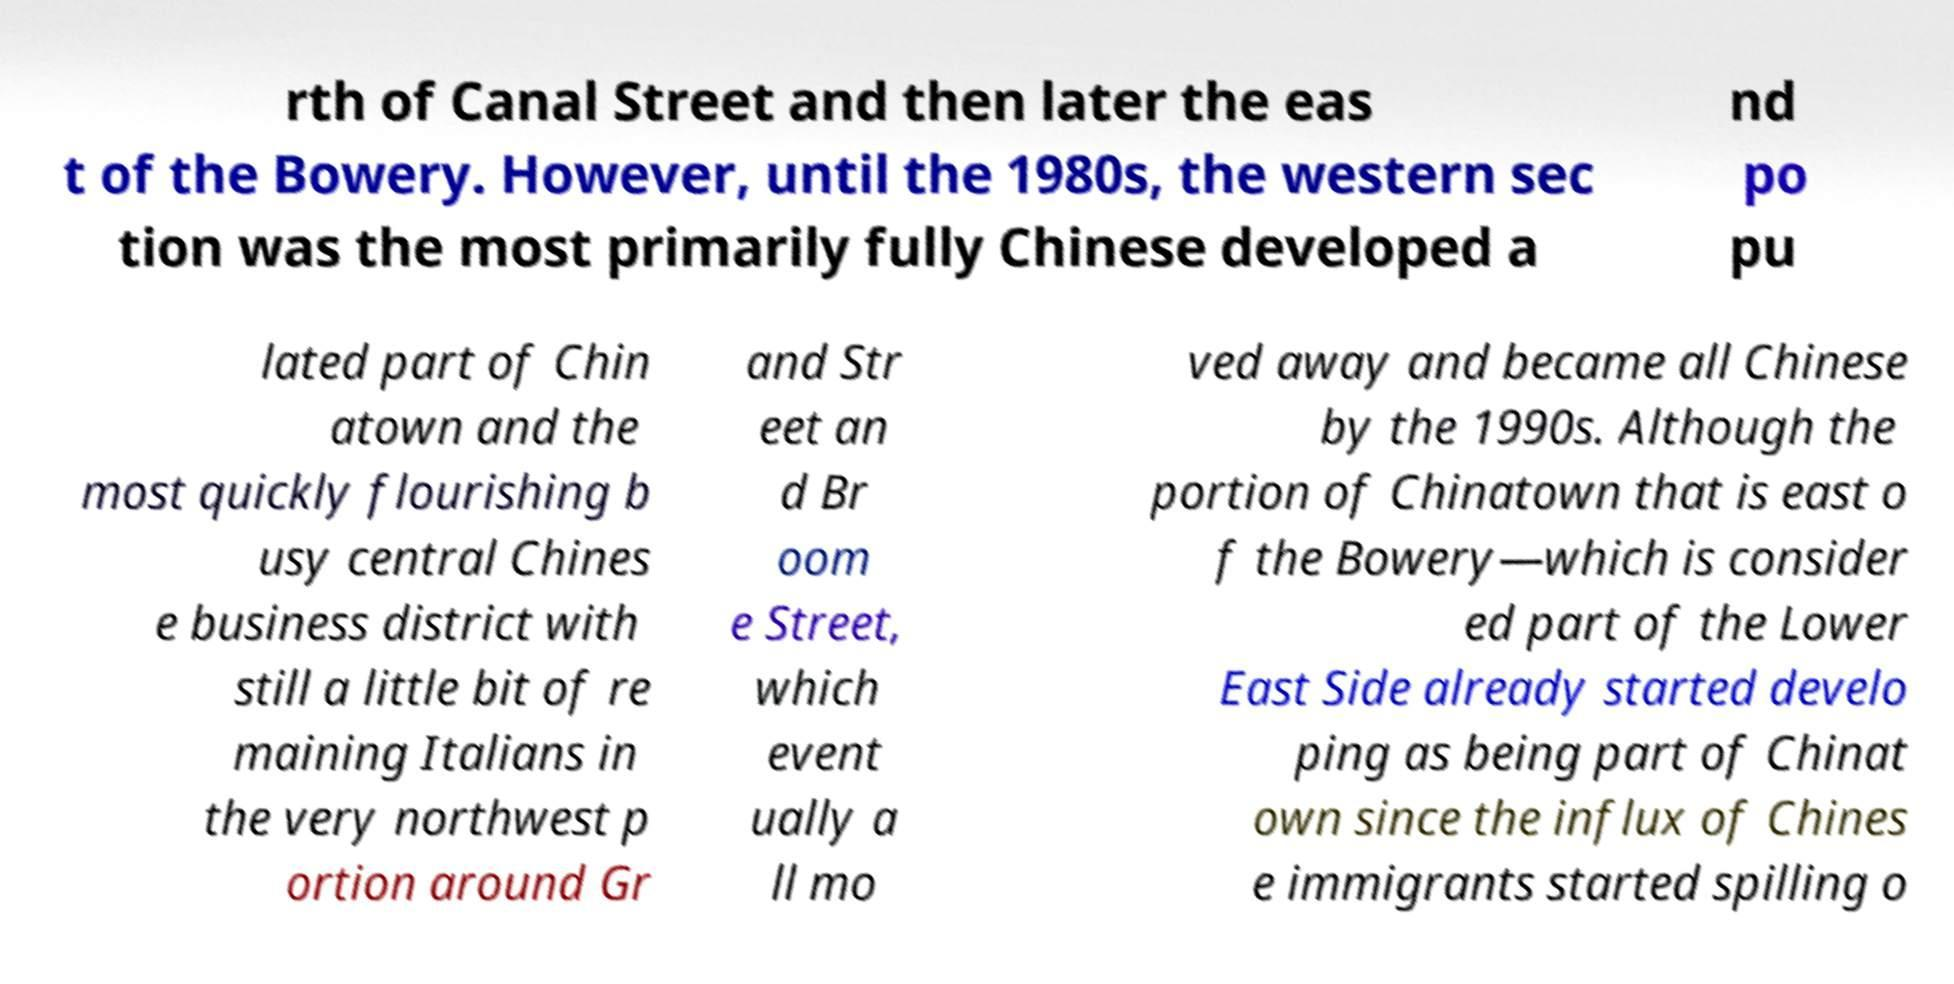Can you read and provide the text displayed in the image?This photo seems to have some interesting text. Can you extract and type it out for me? rth of Canal Street and then later the eas t of the Bowery. However, until the 1980s, the western sec tion was the most primarily fully Chinese developed a nd po pu lated part of Chin atown and the most quickly flourishing b usy central Chines e business district with still a little bit of re maining Italians in the very northwest p ortion around Gr and Str eet an d Br oom e Street, which event ually a ll mo ved away and became all Chinese by the 1990s. Although the portion of Chinatown that is east o f the Bowery—which is consider ed part of the Lower East Side already started develo ping as being part of Chinat own since the influx of Chines e immigrants started spilling o 